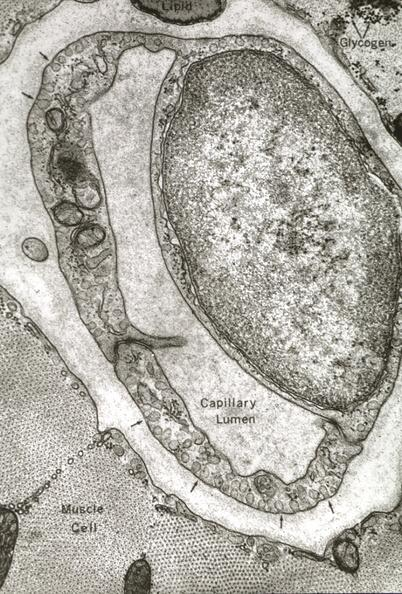s this photo of infant from head to toe present?
Answer the question using a single word or phrase. No 